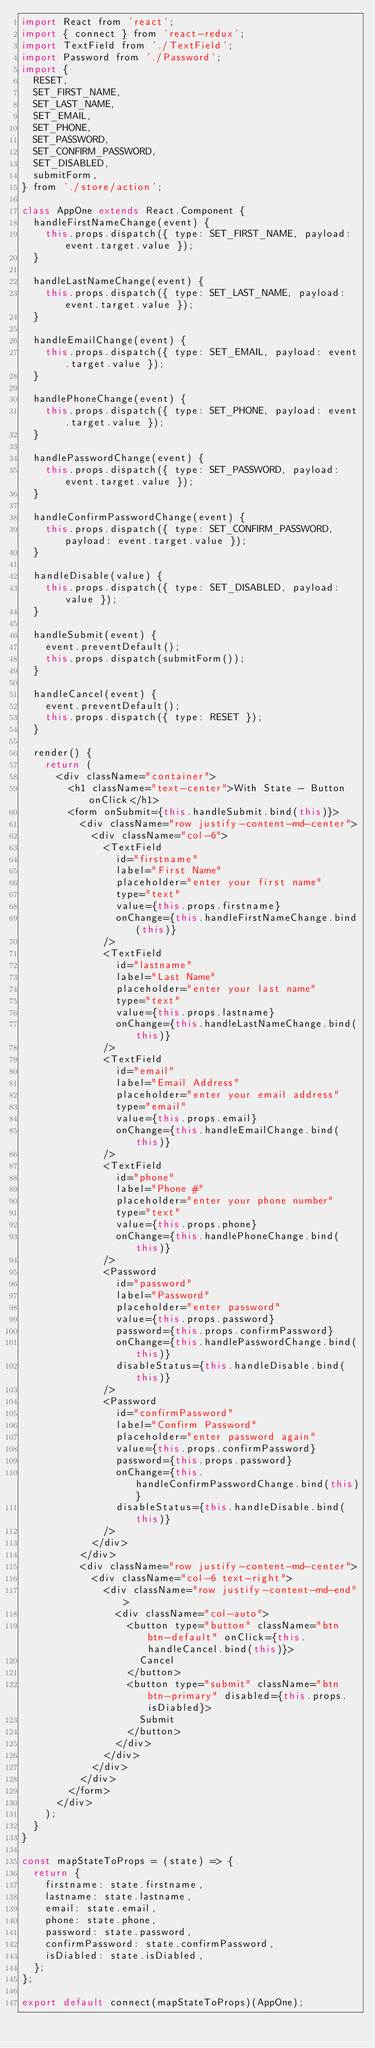<code> <loc_0><loc_0><loc_500><loc_500><_JavaScript_>import React from 'react';
import { connect } from 'react-redux';
import TextField from './TextField';
import Password from './Password';
import {
  RESET,
  SET_FIRST_NAME,
  SET_LAST_NAME,
  SET_EMAIL,
  SET_PHONE,
  SET_PASSWORD,
  SET_CONFIRM_PASSWORD,
  SET_DISABLED,
  submitForm,
} from './store/action';

class AppOne extends React.Component {
  handleFirstNameChange(event) {
    this.props.dispatch({ type: SET_FIRST_NAME, payload: event.target.value });
  }

  handleLastNameChange(event) {
    this.props.dispatch({ type: SET_LAST_NAME, payload: event.target.value });
  }

  handleEmailChange(event) {
    this.props.dispatch({ type: SET_EMAIL, payload: event.target.value });
  }

  handlePhoneChange(event) {
    this.props.dispatch({ type: SET_PHONE, payload: event.target.value });
  }

  handlePasswordChange(event) {
    this.props.dispatch({ type: SET_PASSWORD, payload: event.target.value });
  }

  handleConfirmPasswordChange(event) {
    this.props.dispatch({ type: SET_CONFIRM_PASSWORD, payload: event.target.value });
  }

  handleDisable(value) {
    this.props.dispatch({ type: SET_DISABLED, payload: value });
  }

  handleSubmit(event) {
    event.preventDefault();
    this.props.dispatch(submitForm());
  }

  handleCancel(event) {
    event.preventDefault();
    this.props.dispatch({ type: RESET });
  }

  render() {
    return (
      <div className="container">
        <h1 className="text-center">With State - Button onClick</h1>
        <form onSubmit={this.handleSubmit.bind(this)}>
          <div className="row justify-content-md-center">
            <div className="col-6">
              <TextField
                id="firstname"
                label="First Name"
                placeholder="enter your first name"
                type="text"
                value={this.props.firstname}
                onChange={this.handleFirstNameChange.bind(this)}
              />
              <TextField
                id="lastname"
                label="Last Name"
                placeholder="enter your last name"
                type="text"
                value={this.props.lastname}
                onChange={this.handleLastNameChange.bind(this)}
              />
              <TextField
                id="email"
                label="Email Address"
                placeholder="enter your email address"
                type="email"
                value={this.props.email}
                onChange={this.handleEmailChange.bind(this)}
              />
              <TextField
                id="phone"
                label="Phone #"
                placeholder="enter your phone number"
                type="text"
                value={this.props.phone}
                onChange={this.handlePhoneChange.bind(this)}
              />
              <Password
                id="password"
                label="Password"
                placeholder="enter password"
                value={this.props.password}
                password={this.props.confirmPassword}
                onChange={this.handlePasswordChange.bind(this)}
                disableStatus={this.handleDisable.bind(this)}
              />
              <Password
                id="confirmPassword"
                label="Confirm Password"
                placeholder="enter password again"
                value={this.props.confirmPassword}
                password={this.props.password}
                onChange={this.handleConfirmPasswordChange.bind(this)}
                disableStatus={this.handleDisable.bind(this)}
              />
            </div>
          </div>
          <div className="row justify-content-md-center">
            <div className="col-6 text-right">
              <div className="row justify-content-md-end">
                <div className="col-auto">
                  <button type="button" className="btn btn-default" onClick={this.handleCancel.bind(this)}>
                    Cancel
                  </button>
                  <button type="submit" className="btn btn-primary" disabled={this.props.isDiabled}>
                    Submit
                  </button>
                </div>
              </div>
            </div>
          </div>
        </form>
      </div>
    );
  }
}

const mapStateToProps = (state) => {
  return {
    firstname: state.firstname,
    lastname: state.lastname,
    email: state.email,
    phone: state.phone,
    password: state.password,
    confirmPassword: state.confirmPassword,
    isDiabled: state.isDiabled,
  };
};

export default connect(mapStateToProps)(AppOne);
</code> 